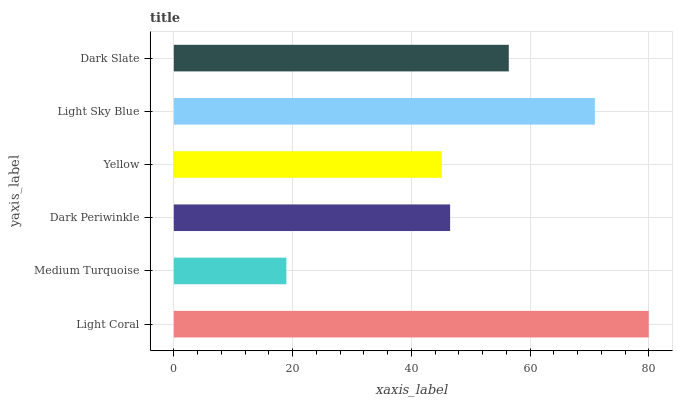Is Medium Turquoise the minimum?
Answer yes or no. Yes. Is Light Coral the maximum?
Answer yes or no. Yes. Is Dark Periwinkle the minimum?
Answer yes or no. No. Is Dark Periwinkle the maximum?
Answer yes or no. No. Is Dark Periwinkle greater than Medium Turquoise?
Answer yes or no. Yes. Is Medium Turquoise less than Dark Periwinkle?
Answer yes or no. Yes. Is Medium Turquoise greater than Dark Periwinkle?
Answer yes or no. No. Is Dark Periwinkle less than Medium Turquoise?
Answer yes or no. No. Is Dark Slate the high median?
Answer yes or no. Yes. Is Dark Periwinkle the low median?
Answer yes or no. Yes. Is Light Coral the high median?
Answer yes or no. No. Is Medium Turquoise the low median?
Answer yes or no. No. 